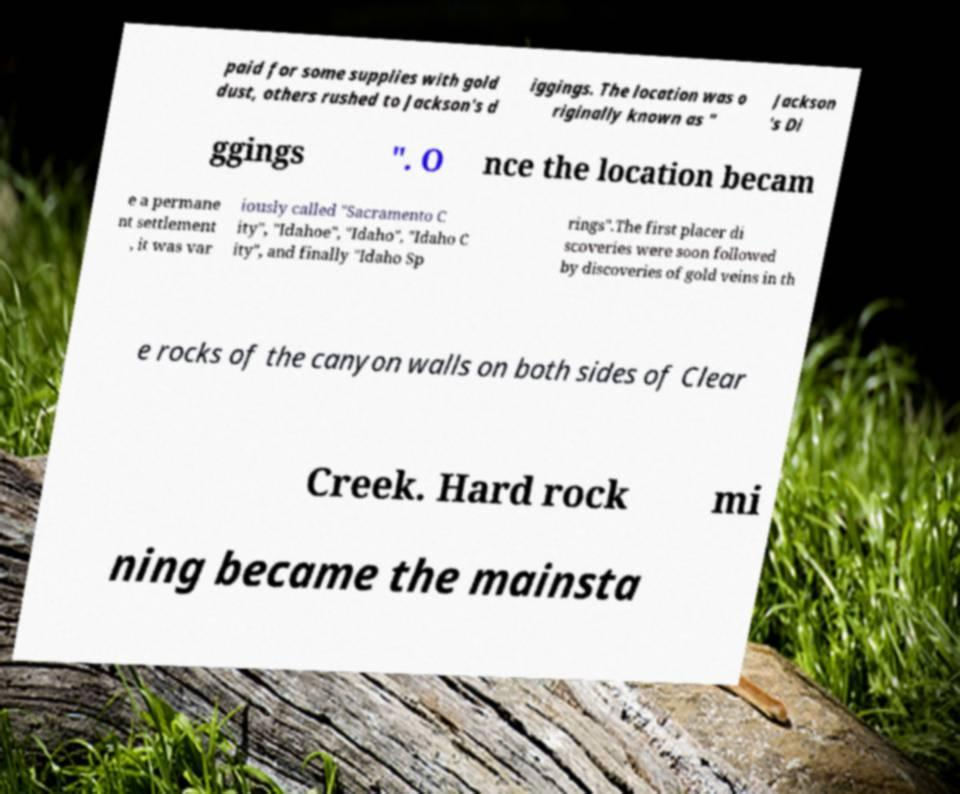There's text embedded in this image that I need extracted. Can you transcribe it verbatim? paid for some supplies with gold dust, others rushed to Jackson's d iggings. The location was o riginally known as " Jackson 's Di ggings ". O nce the location becam e a permane nt settlement , it was var iously called "Sacramento C ity", "Idahoe", "Idaho", "Idaho C ity", and finally "Idaho Sp rings".The first placer di scoveries were soon followed by discoveries of gold veins in th e rocks of the canyon walls on both sides of Clear Creek. Hard rock mi ning became the mainsta 